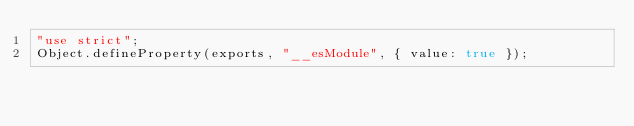<code> <loc_0><loc_0><loc_500><loc_500><_JavaScript_>"use strict";
Object.defineProperty(exports, "__esModule", { value: true });</code> 